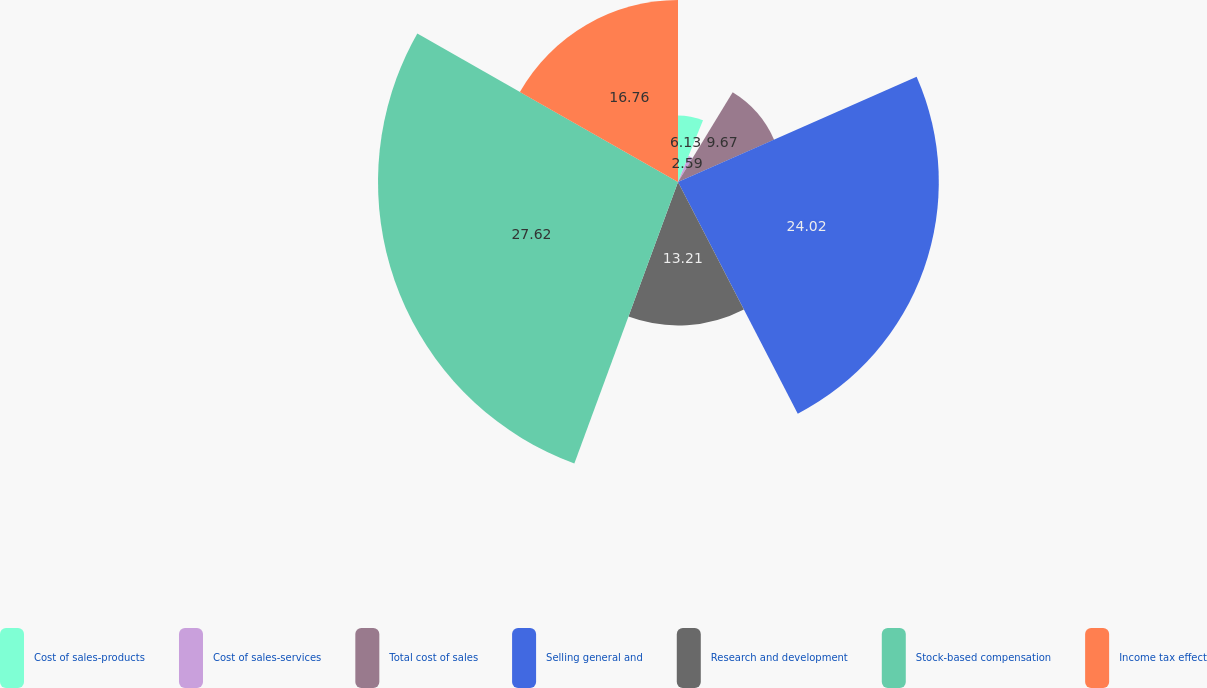Convert chart to OTSL. <chart><loc_0><loc_0><loc_500><loc_500><pie_chart><fcel>Cost of sales-products<fcel>Cost of sales-services<fcel>Total cost of sales<fcel>Selling general and<fcel>Research and development<fcel>Stock-based compensation<fcel>Income tax effect<nl><fcel>6.13%<fcel>2.59%<fcel>9.67%<fcel>24.02%<fcel>13.21%<fcel>27.63%<fcel>16.76%<nl></chart> 